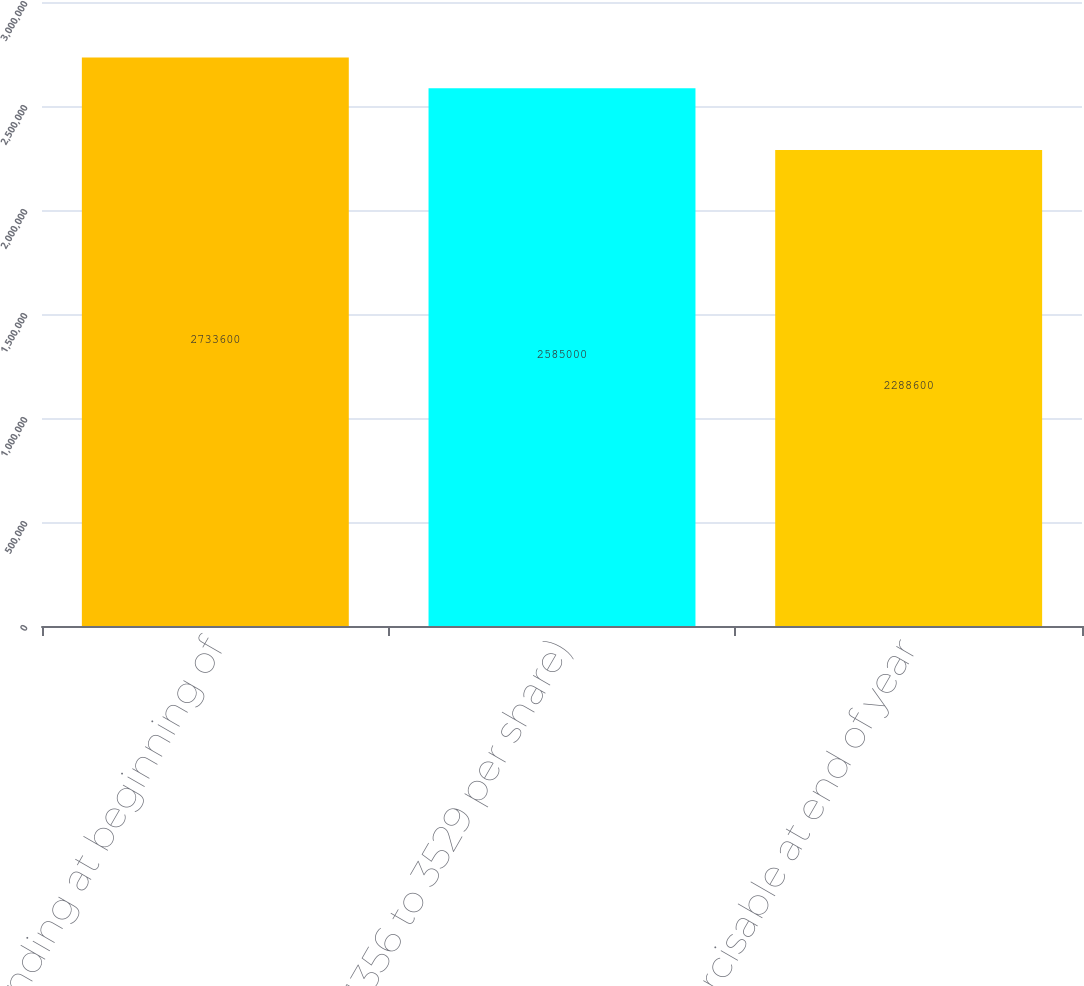Convert chart. <chart><loc_0><loc_0><loc_500><loc_500><bar_chart><fcel>Outstanding at beginning of<fcel>(2004-1356 to 3529 per share)<fcel>Exercisable at end of year<nl><fcel>2.7336e+06<fcel>2.585e+06<fcel>2.2886e+06<nl></chart> 